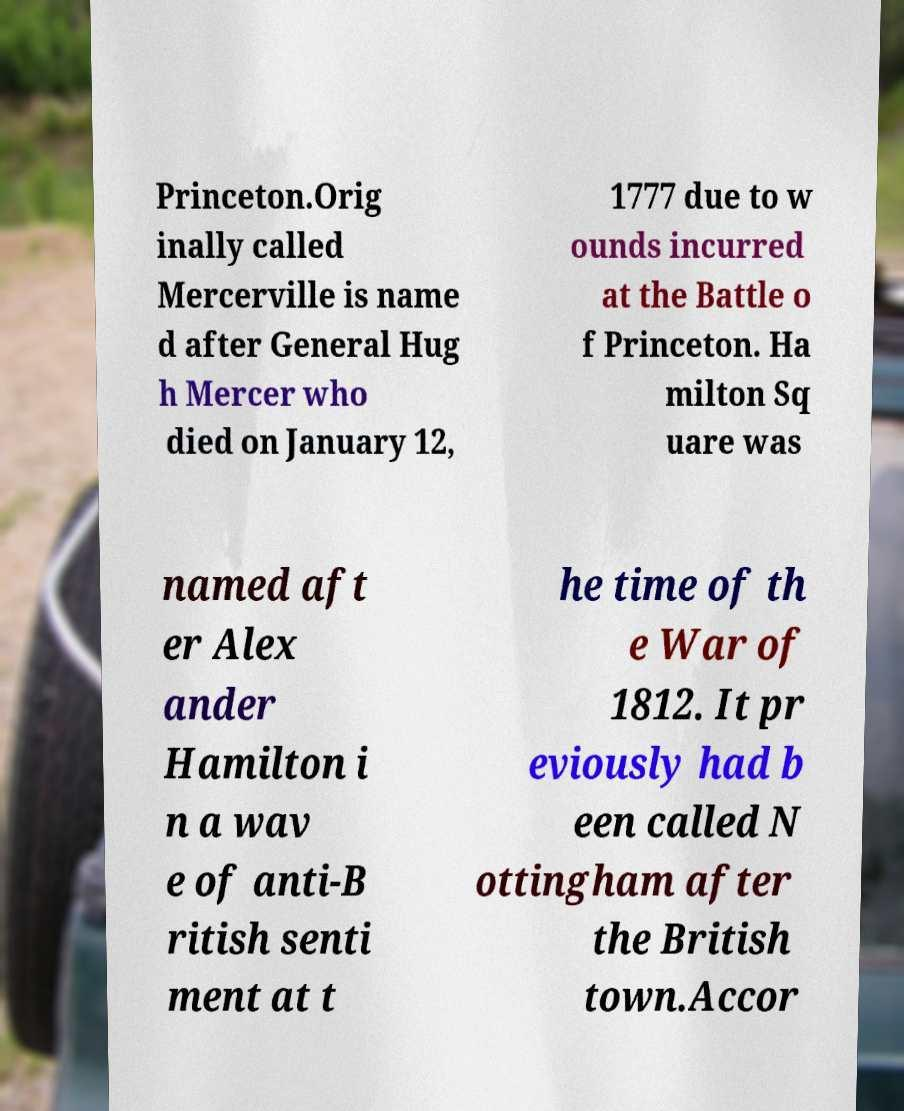Could you assist in decoding the text presented in this image and type it out clearly? Princeton.Orig inally called Mercerville is name d after General Hug h Mercer who died on January 12, 1777 due to w ounds incurred at the Battle o f Princeton. Ha milton Sq uare was named aft er Alex ander Hamilton i n a wav e of anti-B ritish senti ment at t he time of th e War of 1812. It pr eviously had b een called N ottingham after the British town.Accor 